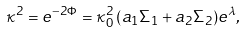<formula> <loc_0><loc_0><loc_500><loc_500>\kappa ^ { 2 } = e ^ { - 2 \Phi } = \kappa _ { 0 } ^ { 2 } \, ( a _ { 1 } \Sigma _ { 1 } + a _ { 2 } \Sigma _ { 2 } ) e ^ { \lambda } ,</formula> 